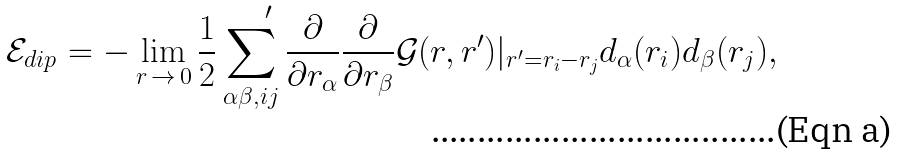Convert formula to latex. <formula><loc_0><loc_0><loc_500><loc_500>\mathcal { E } _ { d i p } = - \lim _ { r \, \to \, 0 } \frac { 1 } { 2 } \sum _ { \alpha \beta , i j } ^ { \quad \prime } \frac { \partial } { \partial r _ { \alpha } } \frac { \partial } { \partial r _ { \beta } } \mathcal { G } ( r , r ^ { \prime } ) | _ { r ^ { \prime } = r _ { i } - r _ { j } } d _ { \alpha } ( r _ { i } ) d _ { \beta } ( r _ { j } ) ,</formula> 